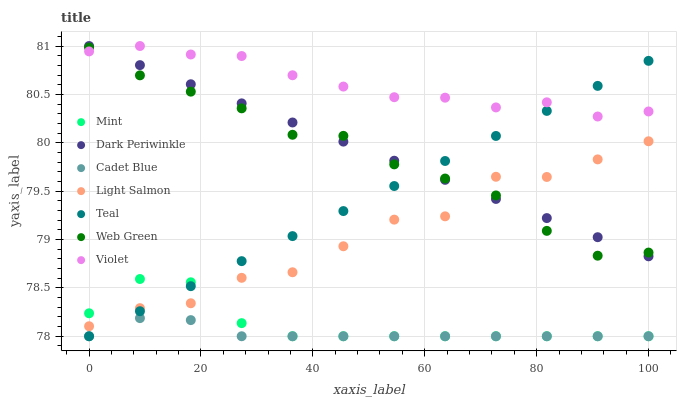Does Cadet Blue have the minimum area under the curve?
Answer yes or no. Yes. Does Violet have the maximum area under the curve?
Answer yes or no. Yes. Does Web Green have the minimum area under the curve?
Answer yes or no. No. Does Web Green have the maximum area under the curve?
Answer yes or no. No. Is Dark Periwinkle the smoothest?
Answer yes or no. Yes. Is Light Salmon the roughest?
Answer yes or no. Yes. Is Cadet Blue the smoothest?
Answer yes or no. No. Is Cadet Blue the roughest?
Answer yes or no. No. Does Cadet Blue have the lowest value?
Answer yes or no. Yes. Does Web Green have the lowest value?
Answer yes or no. No. Does Dark Periwinkle have the highest value?
Answer yes or no. Yes. Does Web Green have the highest value?
Answer yes or no. No. Is Cadet Blue less than Web Green?
Answer yes or no. Yes. Is Web Green greater than Cadet Blue?
Answer yes or no. Yes. Does Light Salmon intersect Dark Periwinkle?
Answer yes or no. Yes. Is Light Salmon less than Dark Periwinkle?
Answer yes or no. No. Is Light Salmon greater than Dark Periwinkle?
Answer yes or no. No. Does Cadet Blue intersect Web Green?
Answer yes or no. No. 